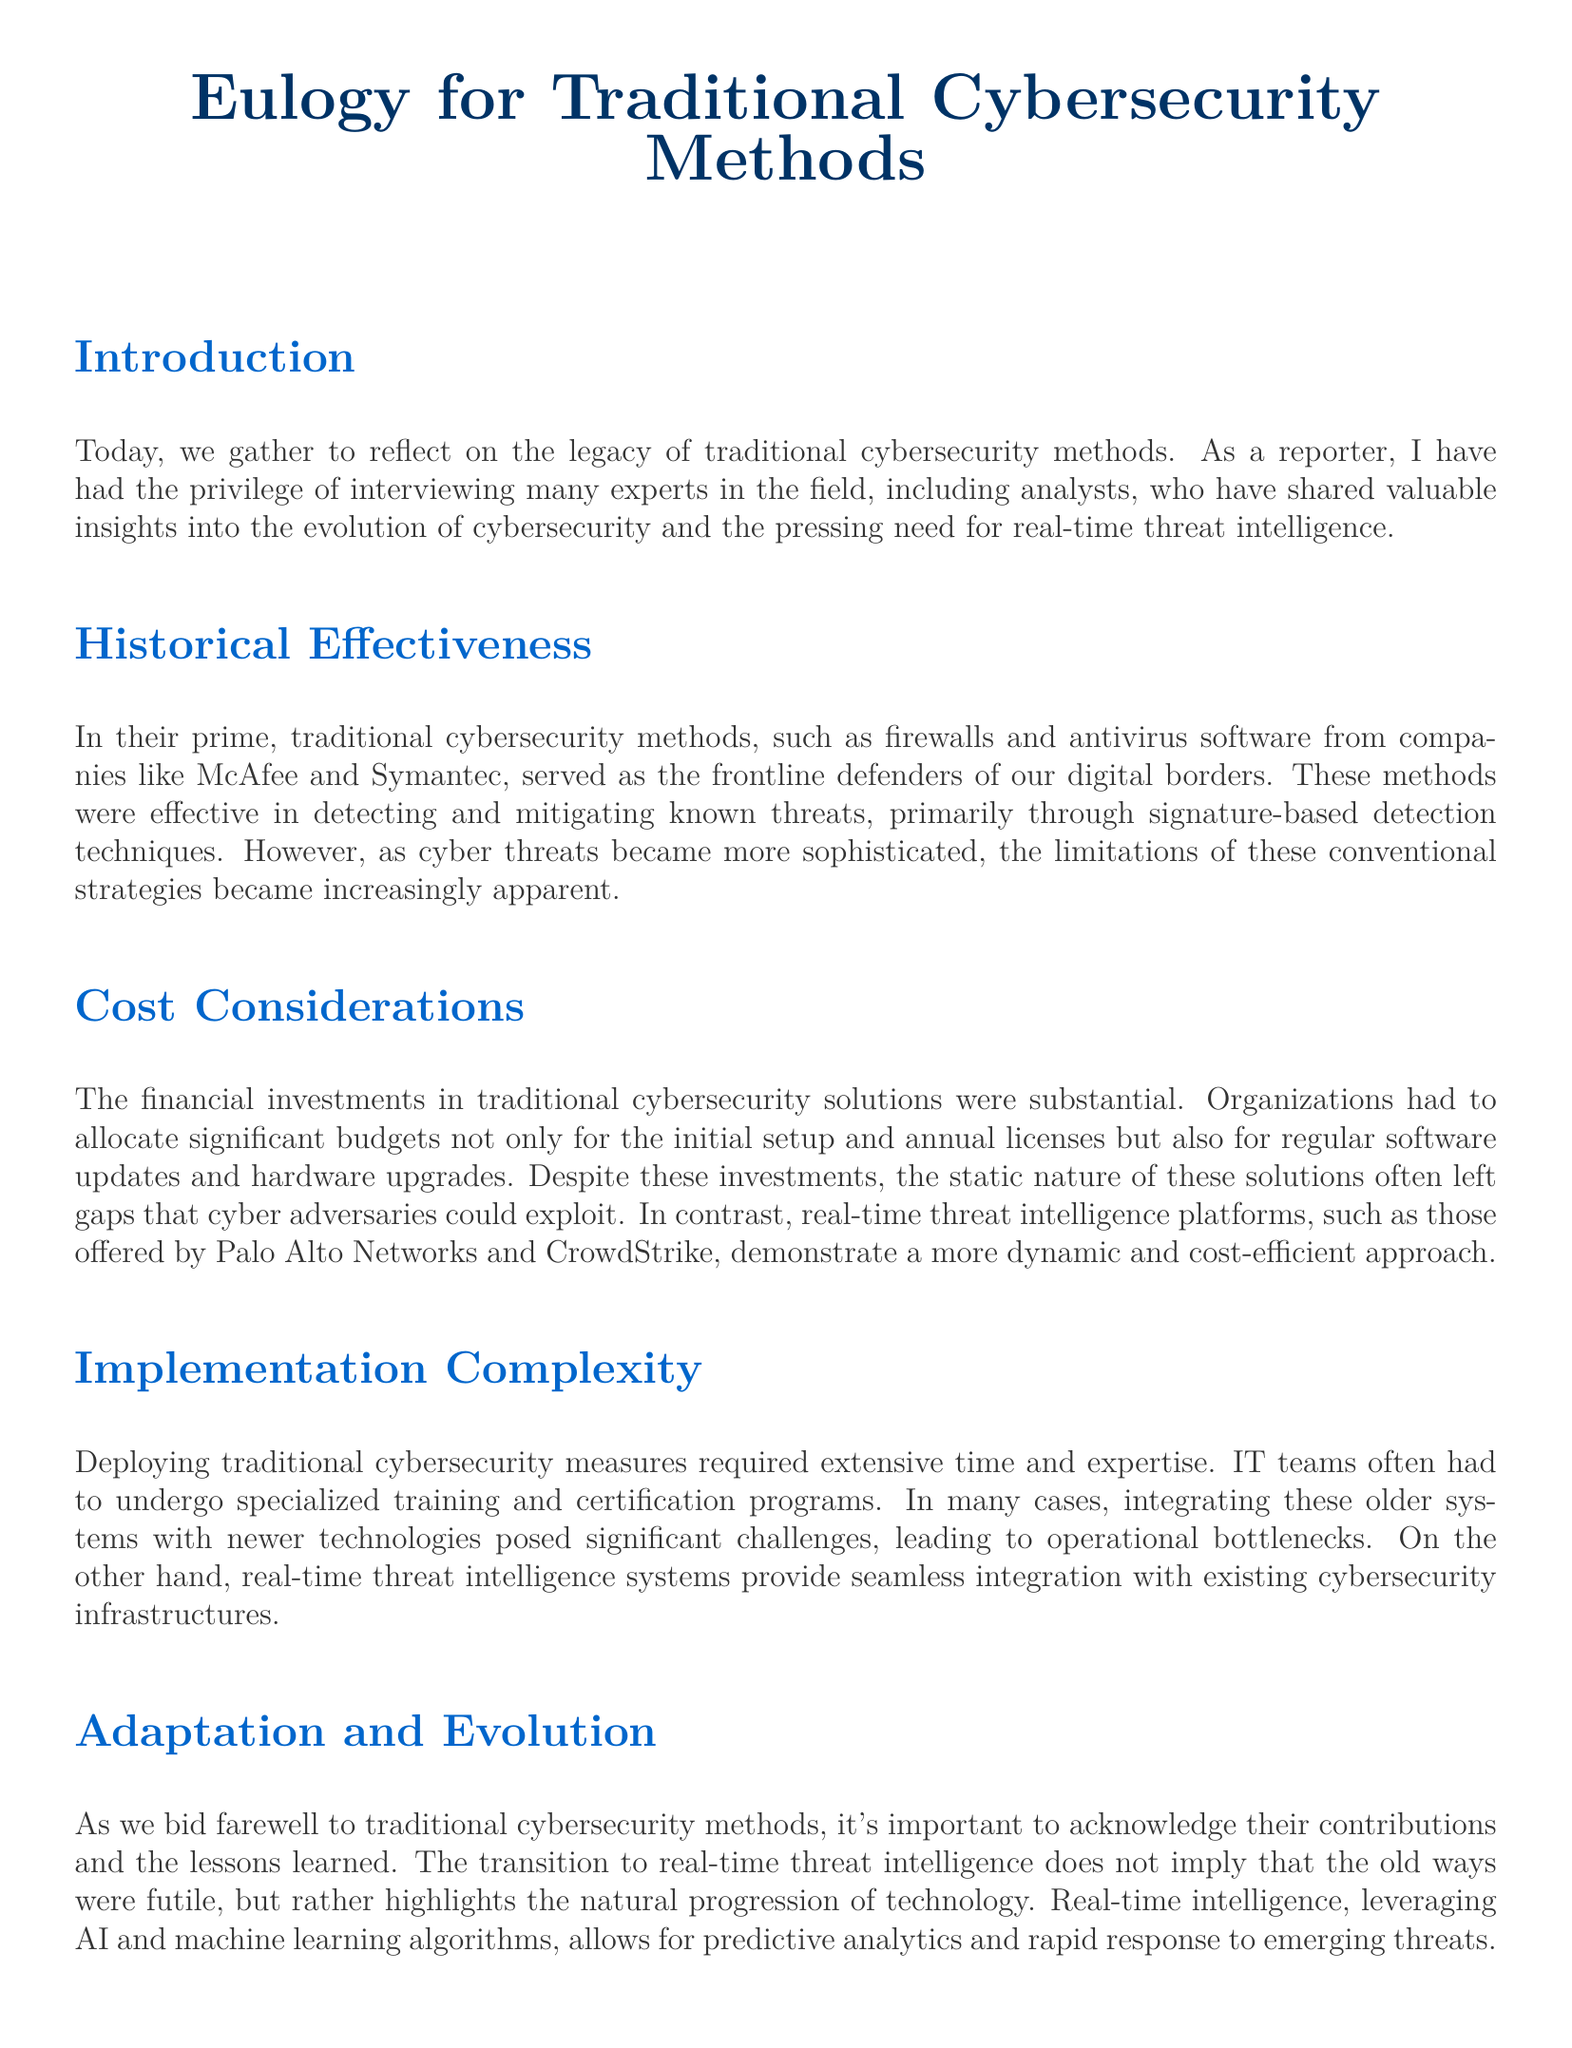What is the title of the document? The title of the document is prominently displayed at the top and serves to convey the main theme.
Answer: Eulogy for Traditional Cybersecurity Methods What are two traditional cybersecurity methods mentioned? The document lists specific traditional cybersecurity methods as examples of what was used.
Answer: Firewalls and antivirus software Which companies are cited as providers of traditional cybersecurity solutions? The document references companies that developed traditional cybersecurity methods, highlighting their recognition in the field.
Answer: McAfee and Symantec What approach does real-time threat intelligence demonstrate compared to traditional methods? The document contrasts real-time threat intelligence with traditional methods, emphasizing differences in efficiency and strategy.
Answer: More dynamic and cost-efficient What kind of technologies do real-time threat intelligence systems utilize? The document attributes advanced technological solutions for real-time threat intelligence, focusing on modern advancements.
Answer: AI and machine learning What challenge is associated with implementing traditional cybersecurity measures? The document describes the difficulties faced during the deployment of older cybersecurity solutions, pointing to the required expertise.
Answer: Extensive time and expertise What is a key advantage of real-time threat intelligence over traditional methods? The document outlines a specific benefit that real-time intelligence systems have over traditional cybersecurity measures.
Answer: Superior effectiveness In what context is the phrase "natural progression of technology" used? The document notes this phrase in reference to the transition from traditional methods to newer technologies, providing insight into its relevance.
Answer: Adaptation and Evolution What call to action does the conclusion make regarding cybersecurity systems? The conclusion emphasizes a specific recommendation for organizations regarding cybersecurity practices in the evolving landscape.
Answer: Adopt these advanced systems 